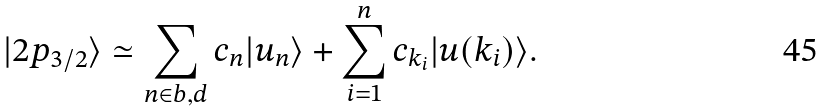<formula> <loc_0><loc_0><loc_500><loc_500>| 2 p _ { 3 / 2 } \rangle \simeq \sum _ { n \in b , d } c _ { n } | u _ { n } \rangle + \sum _ { i = 1 } ^ { n } c _ { k _ { i } } | u ( k _ { i } ) \rangle .</formula> 